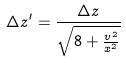<formula> <loc_0><loc_0><loc_500><loc_500>\Delta z ^ { \prime } = \frac { \Delta z } { \sqrt { 8 + \frac { v ^ { 2 } } { x ^ { 2 } } } }</formula> 